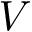Convert formula to latex. <formula><loc_0><loc_0><loc_500><loc_500>V</formula> 